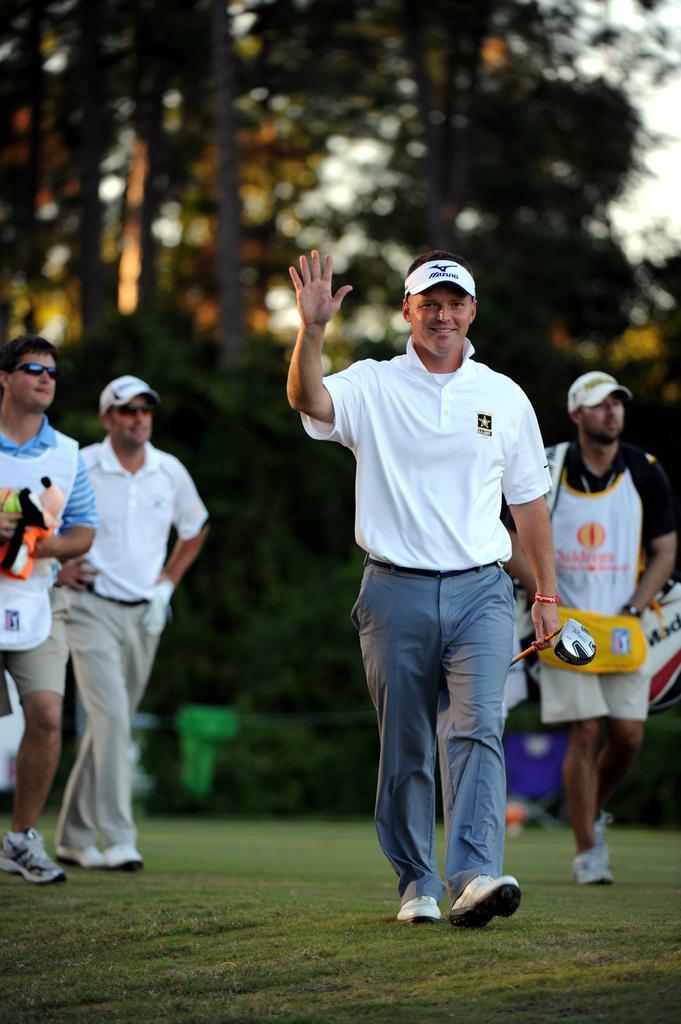Could you give a brief overview of what you see in this image? In the center of the image we can see some persons are walking and some of them are holding objects and wearing cap. In the background of the image we can see trees, boards. At the bottom of the image there is a ground. At the top right corner we can see the sky. 